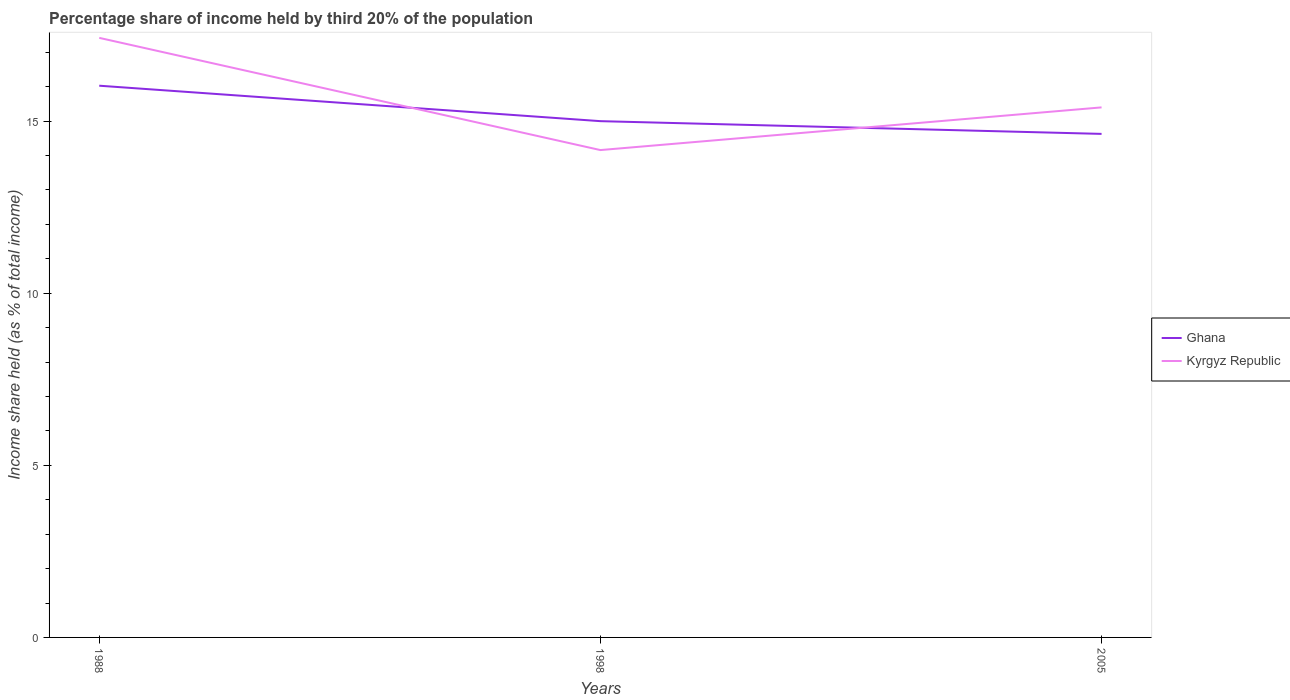Across all years, what is the maximum share of income held by third 20% of the population in Ghana?
Give a very brief answer. 14.63. What is the total share of income held by third 20% of the population in Kyrgyz Republic in the graph?
Your response must be concise. 3.26. What is the difference between the highest and the second highest share of income held by third 20% of the population in Kyrgyz Republic?
Make the answer very short. 3.26. Is the share of income held by third 20% of the population in Ghana strictly greater than the share of income held by third 20% of the population in Kyrgyz Republic over the years?
Your response must be concise. No. Does the graph contain grids?
Give a very brief answer. No. What is the title of the graph?
Make the answer very short. Percentage share of income held by third 20% of the population. Does "Botswana" appear as one of the legend labels in the graph?
Give a very brief answer. No. What is the label or title of the Y-axis?
Keep it short and to the point. Income share held (as % of total income). What is the Income share held (as % of total income) of Ghana in 1988?
Offer a terse response. 16.03. What is the Income share held (as % of total income) of Kyrgyz Republic in 1988?
Your answer should be compact. 17.42. What is the Income share held (as % of total income) of Ghana in 1998?
Your answer should be very brief. 15. What is the Income share held (as % of total income) of Kyrgyz Republic in 1998?
Offer a terse response. 14.16. What is the Income share held (as % of total income) in Ghana in 2005?
Your answer should be compact. 14.63. Across all years, what is the maximum Income share held (as % of total income) in Ghana?
Provide a succinct answer. 16.03. Across all years, what is the maximum Income share held (as % of total income) in Kyrgyz Republic?
Your answer should be very brief. 17.42. Across all years, what is the minimum Income share held (as % of total income) in Ghana?
Make the answer very short. 14.63. Across all years, what is the minimum Income share held (as % of total income) of Kyrgyz Republic?
Keep it short and to the point. 14.16. What is the total Income share held (as % of total income) in Ghana in the graph?
Ensure brevity in your answer.  45.66. What is the total Income share held (as % of total income) of Kyrgyz Republic in the graph?
Offer a very short reply. 46.98. What is the difference between the Income share held (as % of total income) of Ghana in 1988 and that in 1998?
Offer a terse response. 1.03. What is the difference between the Income share held (as % of total income) of Kyrgyz Republic in 1988 and that in 1998?
Make the answer very short. 3.26. What is the difference between the Income share held (as % of total income) of Kyrgyz Republic in 1988 and that in 2005?
Your response must be concise. 2.02. What is the difference between the Income share held (as % of total income) in Ghana in 1998 and that in 2005?
Offer a very short reply. 0.37. What is the difference between the Income share held (as % of total income) in Kyrgyz Republic in 1998 and that in 2005?
Your response must be concise. -1.24. What is the difference between the Income share held (as % of total income) in Ghana in 1988 and the Income share held (as % of total income) in Kyrgyz Republic in 1998?
Give a very brief answer. 1.87. What is the difference between the Income share held (as % of total income) in Ghana in 1988 and the Income share held (as % of total income) in Kyrgyz Republic in 2005?
Give a very brief answer. 0.63. What is the average Income share held (as % of total income) in Ghana per year?
Your answer should be very brief. 15.22. What is the average Income share held (as % of total income) of Kyrgyz Republic per year?
Your response must be concise. 15.66. In the year 1988, what is the difference between the Income share held (as % of total income) of Ghana and Income share held (as % of total income) of Kyrgyz Republic?
Ensure brevity in your answer.  -1.39. In the year 1998, what is the difference between the Income share held (as % of total income) of Ghana and Income share held (as % of total income) of Kyrgyz Republic?
Your answer should be compact. 0.84. In the year 2005, what is the difference between the Income share held (as % of total income) of Ghana and Income share held (as % of total income) of Kyrgyz Republic?
Ensure brevity in your answer.  -0.77. What is the ratio of the Income share held (as % of total income) in Ghana in 1988 to that in 1998?
Keep it short and to the point. 1.07. What is the ratio of the Income share held (as % of total income) of Kyrgyz Republic in 1988 to that in 1998?
Offer a terse response. 1.23. What is the ratio of the Income share held (as % of total income) of Ghana in 1988 to that in 2005?
Keep it short and to the point. 1.1. What is the ratio of the Income share held (as % of total income) of Kyrgyz Republic in 1988 to that in 2005?
Offer a terse response. 1.13. What is the ratio of the Income share held (as % of total income) in Ghana in 1998 to that in 2005?
Keep it short and to the point. 1.03. What is the ratio of the Income share held (as % of total income) of Kyrgyz Republic in 1998 to that in 2005?
Give a very brief answer. 0.92. What is the difference between the highest and the second highest Income share held (as % of total income) of Ghana?
Make the answer very short. 1.03. What is the difference between the highest and the second highest Income share held (as % of total income) in Kyrgyz Republic?
Your answer should be compact. 2.02. What is the difference between the highest and the lowest Income share held (as % of total income) in Ghana?
Your answer should be very brief. 1.4. What is the difference between the highest and the lowest Income share held (as % of total income) in Kyrgyz Republic?
Provide a succinct answer. 3.26. 